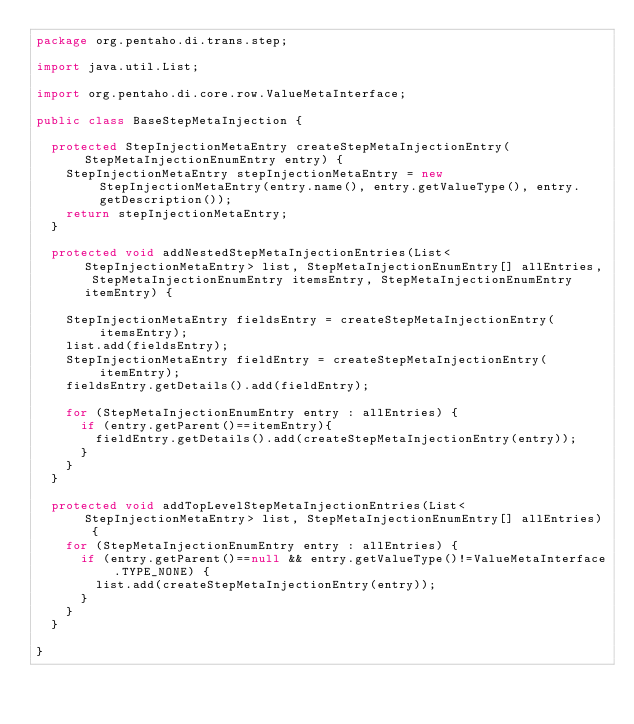<code> <loc_0><loc_0><loc_500><loc_500><_Java_>package org.pentaho.di.trans.step;

import java.util.List;

import org.pentaho.di.core.row.ValueMetaInterface;

public class BaseStepMetaInjection {

  protected StepInjectionMetaEntry createStepMetaInjectionEntry(StepMetaInjectionEnumEntry entry) {
    StepInjectionMetaEntry stepInjectionMetaEntry = new StepInjectionMetaEntry(entry.name(), entry.getValueType(), entry.getDescription());
    return stepInjectionMetaEntry;
  }
  
  protected void addNestedStepMetaInjectionEntries(List<StepInjectionMetaEntry> list, StepMetaInjectionEnumEntry[] allEntries, StepMetaInjectionEnumEntry itemsEntry, StepMetaInjectionEnumEntry itemEntry) {

    StepInjectionMetaEntry fieldsEntry = createStepMetaInjectionEntry(itemsEntry);
    list.add(fieldsEntry);
    StepInjectionMetaEntry fieldEntry = createStepMetaInjectionEntry(itemEntry);
    fieldsEntry.getDetails().add(fieldEntry);

    for (StepMetaInjectionEnumEntry entry : allEntries) {
      if (entry.getParent()==itemEntry){ 
        fieldEntry.getDetails().add(createStepMetaInjectionEntry(entry));
      }
    }
  }
  
  protected void addTopLevelStepMetaInjectionEntries(List<StepInjectionMetaEntry> list, StepMetaInjectionEnumEntry[] allEntries) {
    for (StepMetaInjectionEnumEntry entry : allEntries) {
      if (entry.getParent()==null && entry.getValueType()!=ValueMetaInterface.TYPE_NONE) { 
        list.add(createStepMetaInjectionEntry(entry));
      }
    }
  }
  
}
</code> 